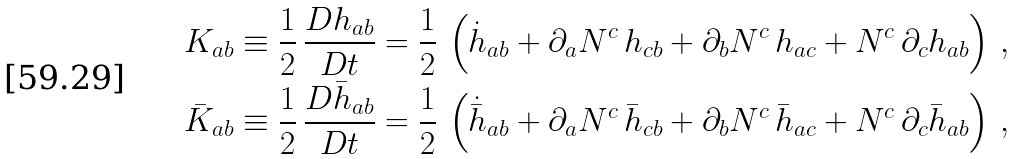Convert formula to latex. <formula><loc_0><loc_0><loc_500><loc_500>K _ { a b } & \equiv \frac { 1 } { 2 } \, \frac { D h _ { a b } } { D t } = \frac { 1 } { 2 } \, \left ( \dot { h } _ { a b } + \partial _ { a } N ^ { c } \, h _ { c b } + \partial _ { b } N ^ { c } \, h _ { a c } + N ^ { c } \, \partial _ { c } h _ { a b } \right ) \, , \\ \bar { K } _ { a b } & \equiv \frac { 1 } { 2 } \, \frac { D \bar { h } _ { a b } } { D t } = \frac { 1 } { 2 } \, \left ( \dot { \bar { h } } _ { a b } + \partial _ { a } N ^ { c } \, \bar { h } _ { c b } + \partial _ { b } N ^ { c } \, \bar { h } _ { a c } + N ^ { c } \, \partial _ { c } \bar { h } _ { a b } \right ) \, ,</formula> 